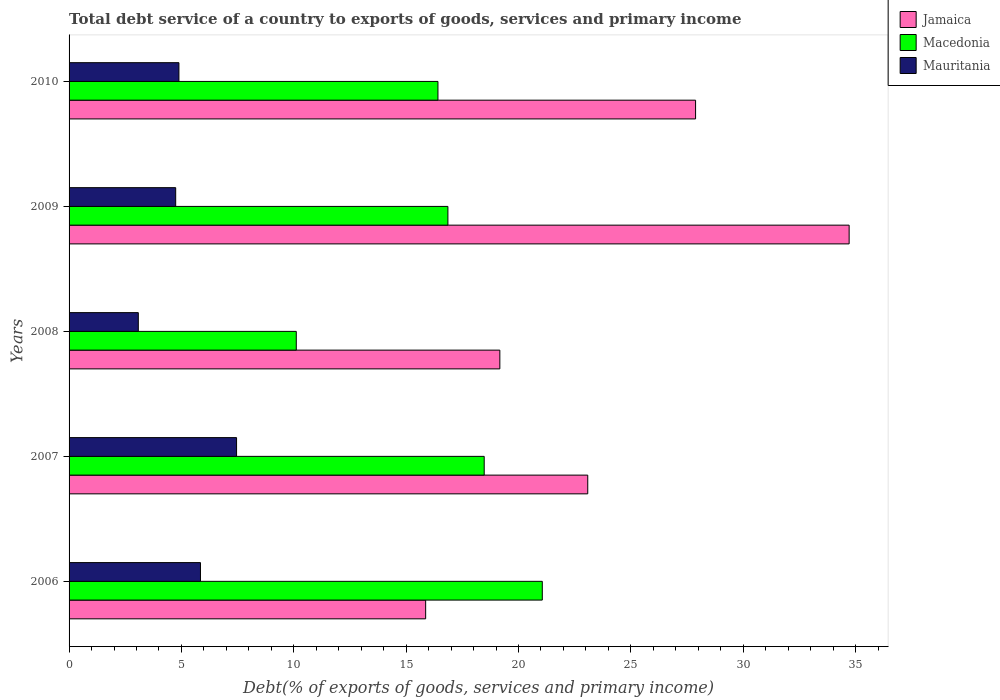In how many cases, is the number of bars for a given year not equal to the number of legend labels?
Give a very brief answer. 0. What is the total debt service in Jamaica in 2009?
Provide a succinct answer. 34.72. Across all years, what is the maximum total debt service in Jamaica?
Your response must be concise. 34.72. Across all years, what is the minimum total debt service in Mauritania?
Provide a succinct answer. 3.08. What is the total total debt service in Mauritania in the graph?
Provide a succinct answer. 26.02. What is the difference between the total debt service in Mauritania in 2007 and that in 2009?
Give a very brief answer. 2.71. What is the difference between the total debt service in Macedonia in 2010 and the total debt service in Jamaica in 2007?
Provide a short and direct response. -6.67. What is the average total debt service in Jamaica per year?
Provide a succinct answer. 24.14. In the year 2006, what is the difference between the total debt service in Mauritania and total debt service in Jamaica?
Make the answer very short. -10.02. What is the ratio of the total debt service in Jamaica in 2007 to that in 2009?
Your answer should be very brief. 0.66. Is the difference between the total debt service in Mauritania in 2006 and 2008 greater than the difference between the total debt service in Jamaica in 2006 and 2008?
Provide a succinct answer. Yes. What is the difference between the highest and the second highest total debt service in Jamaica?
Your response must be concise. 6.83. What is the difference between the highest and the lowest total debt service in Mauritania?
Offer a very short reply. 4.37. In how many years, is the total debt service in Jamaica greater than the average total debt service in Jamaica taken over all years?
Provide a short and direct response. 2. What does the 1st bar from the top in 2008 represents?
Your answer should be compact. Mauritania. What does the 3rd bar from the bottom in 2009 represents?
Make the answer very short. Mauritania. Are all the bars in the graph horizontal?
Make the answer very short. Yes. What is the difference between two consecutive major ticks on the X-axis?
Offer a terse response. 5. Does the graph contain any zero values?
Offer a very short reply. No. Where does the legend appear in the graph?
Your answer should be very brief. Top right. What is the title of the graph?
Keep it short and to the point. Total debt service of a country to exports of goods, services and primary income. What is the label or title of the X-axis?
Keep it short and to the point. Debt(% of exports of goods, services and primary income). What is the Debt(% of exports of goods, services and primary income) in Jamaica in 2006?
Provide a succinct answer. 15.87. What is the Debt(% of exports of goods, services and primary income) of Macedonia in 2006?
Offer a very short reply. 21.06. What is the Debt(% of exports of goods, services and primary income) in Mauritania in 2006?
Offer a very short reply. 5.85. What is the Debt(% of exports of goods, services and primary income) of Jamaica in 2007?
Offer a very short reply. 23.08. What is the Debt(% of exports of goods, services and primary income) in Macedonia in 2007?
Give a very brief answer. 18.47. What is the Debt(% of exports of goods, services and primary income) in Mauritania in 2007?
Give a very brief answer. 7.45. What is the Debt(% of exports of goods, services and primary income) in Jamaica in 2008?
Keep it short and to the point. 19.17. What is the Debt(% of exports of goods, services and primary income) in Macedonia in 2008?
Give a very brief answer. 10.11. What is the Debt(% of exports of goods, services and primary income) of Mauritania in 2008?
Give a very brief answer. 3.08. What is the Debt(% of exports of goods, services and primary income) of Jamaica in 2009?
Offer a very short reply. 34.72. What is the Debt(% of exports of goods, services and primary income) of Macedonia in 2009?
Keep it short and to the point. 16.86. What is the Debt(% of exports of goods, services and primary income) of Mauritania in 2009?
Your answer should be compact. 4.75. What is the Debt(% of exports of goods, services and primary income) in Jamaica in 2010?
Your response must be concise. 27.88. What is the Debt(% of exports of goods, services and primary income) of Macedonia in 2010?
Provide a short and direct response. 16.42. What is the Debt(% of exports of goods, services and primary income) in Mauritania in 2010?
Your response must be concise. 4.89. Across all years, what is the maximum Debt(% of exports of goods, services and primary income) in Jamaica?
Ensure brevity in your answer.  34.72. Across all years, what is the maximum Debt(% of exports of goods, services and primary income) of Macedonia?
Your answer should be compact. 21.06. Across all years, what is the maximum Debt(% of exports of goods, services and primary income) of Mauritania?
Your response must be concise. 7.45. Across all years, what is the minimum Debt(% of exports of goods, services and primary income) in Jamaica?
Your answer should be very brief. 15.87. Across all years, what is the minimum Debt(% of exports of goods, services and primary income) of Macedonia?
Your answer should be very brief. 10.11. Across all years, what is the minimum Debt(% of exports of goods, services and primary income) in Mauritania?
Offer a terse response. 3.08. What is the total Debt(% of exports of goods, services and primary income) in Jamaica in the graph?
Give a very brief answer. 120.72. What is the total Debt(% of exports of goods, services and primary income) of Macedonia in the graph?
Ensure brevity in your answer.  82.92. What is the total Debt(% of exports of goods, services and primary income) of Mauritania in the graph?
Keep it short and to the point. 26.02. What is the difference between the Debt(% of exports of goods, services and primary income) of Jamaica in 2006 and that in 2007?
Your answer should be compact. -7.21. What is the difference between the Debt(% of exports of goods, services and primary income) of Macedonia in 2006 and that in 2007?
Your answer should be compact. 2.59. What is the difference between the Debt(% of exports of goods, services and primary income) in Mauritania in 2006 and that in 2007?
Offer a terse response. -1.61. What is the difference between the Debt(% of exports of goods, services and primary income) of Jamaica in 2006 and that in 2008?
Offer a terse response. -3.3. What is the difference between the Debt(% of exports of goods, services and primary income) of Macedonia in 2006 and that in 2008?
Provide a short and direct response. 10.95. What is the difference between the Debt(% of exports of goods, services and primary income) in Mauritania in 2006 and that in 2008?
Provide a succinct answer. 2.77. What is the difference between the Debt(% of exports of goods, services and primary income) in Jamaica in 2006 and that in 2009?
Your answer should be very brief. -18.85. What is the difference between the Debt(% of exports of goods, services and primary income) in Macedonia in 2006 and that in 2009?
Keep it short and to the point. 4.2. What is the difference between the Debt(% of exports of goods, services and primary income) of Mauritania in 2006 and that in 2009?
Provide a short and direct response. 1.1. What is the difference between the Debt(% of exports of goods, services and primary income) in Jamaica in 2006 and that in 2010?
Ensure brevity in your answer.  -12.01. What is the difference between the Debt(% of exports of goods, services and primary income) in Macedonia in 2006 and that in 2010?
Provide a succinct answer. 4.64. What is the difference between the Debt(% of exports of goods, services and primary income) of Mauritania in 2006 and that in 2010?
Offer a very short reply. 0.96. What is the difference between the Debt(% of exports of goods, services and primary income) of Jamaica in 2007 and that in 2008?
Make the answer very short. 3.91. What is the difference between the Debt(% of exports of goods, services and primary income) of Macedonia in 2007 and that in 2008?
Offer a very short reply. 8.36. What is the difference between the Debt(% of exports of goods, services and primary income) of Mauritania in 2007 and that in 2008?
Give a very brief answer. 4.37. What is the difference between the Debt(% of exports of goods, services and primary income) in Jamaica in 2007 and that in 2009?
Offer a very short reply. -11.63. What is the difference between the Debt(% of exports of goods, services and primary income) in Macedonia in 2007 and that in 2009?
Provide a succinct answer. 1.61. What is the difference between the Debt(% of exports of goods, services and primary income) in Mauritania in 2007 and that in 2009?
Offer a very short reply. 2.71. What is the difference between the Debt(% of exports of goods, services and primary income) of Jamaica in 2007 and that in 2010?
Provide a short and direct response. -4.8. What is the difference between the Debt(% of exports of goods, services and primary income) of Macedonia in 2007 and that in 2010?
Ensure brevity in your answer.  2.06. What is the difference between the Debt(% of exports of goods, services and primary income) in Mauritania in 2007 and that in 2010?
Provide a short and direct response. 2.56. What is the difference between the Debt(% of exports of goods, services and primary income) of Jamaica in 2008 and that in 2009?
Your answer should be very brief. -15.55. What is the difference between the Debt(% of exports of goods, services and primary income) in Macedonia in 2008 and that in 2009?
Give a very brief answer. -6.75. What is the difference between the Debt(% of exports of goods, services and primary income) of Mauritania in 2008 and that in 2009?
Your answer should be very brief. -1.66. What is the difference between the Debt(% of exports of goods, services and primary income) of Jamaica in 2008 and that in 2010?
Offer a terse response. -8.71. What is the difference between the Debt(% of exports of goods, services and primary income) in Macedonia in 2008 and that in 2010?
Offer a terse response. -6.3. What is the difference between the Debt(% of exports of goods, services and primary income) in Mauritania in 2008 and that in 2010?
Give a very brief answer. -1.81. What is the difference between the Debt(% of exports of goods, services and primary income) of Jamaica in 2009 and that in 2010?
Your response must be concise. 6.83. What is the difference between the Debt(% of exports of goods, services and primary income) in Macedonia in 2009 and that in 2010?
Keep it short and to the point. 0.44. What is the difference between the Debt(% of exports of goods, services and primary income) of Mauritania in 2009 and that in 2010?
Provide a short and direct response. -0.14. What is the difference between the Debt(% of exports of goods, services and primary income) of Jamaica in 2006 and the Debt(% of exports of goods, services and primary income) of Macedonia in 2007?
Your answer should be compact. -2.61. What is the difference between the Debt(% of exports of goods, services and primary income) in Jamaica in 2006 and the Debt(% of exports of goods, services and primary income) in Mauritania in 2007?
Offer a very short reply. 8.42. What is the difference between the Debt(% of exports of goods, services and primary income) in Macedonia in 2006 and the Debt(% of exports of goods, services and primary income) in Mauritania in 2007?
Offer a very short reply. 13.61. What is the difference between the Debt(% of exports of goods, services and primary income) of Jamaica in 2006 and the Debt(% of exports of goods, services and primary income) of Macedonia in 2008?
Provide a short and direct response. 5.76. What is the difference between the Debt(% of exports of goods, services and primary income) of Jamaica in 2006 and the Debt(% of exports of goods, services and primary income) of Mauritania in 2008?
Your answer should be very brief. 12.79. What is the difference between the Debt(% of exports of goods, services and primary income) in Macedonia in 2006 and the Debt(% of exports of goods, services and primary income) in Mauritania in 2008?
Your answer should be very brief. 17.98. What is the difference between the Debt(% of exports of goods, services and primary income) in Jamaica in 2006 and the Debt(% of exports of goods, services and primary income) in Macedonia in 2009?
Give a very brief answer. -0.99. What is the difference between the Debt(% of exports of goods, services and primary income) of Jamaica in 2006 and the Debt(% of exports of goods, services and primary income) of Mauritania in 2009?
Your answer should be very brief. 11.12. What is the difference between the Debt(% of exports of goods, services and primary income) of Macedonia in 2006 and the Debt(% of exports of goods, services and primary income) of Mauritania in 2009?
Provide a succinct answer. 16.32. What is the difference between the Debt(% of exports of goods, services and primary income) of Jamaica in 2006 and the Debt(% of exports of goods, services and primary income) of Macedonia in 2010?
Offer a terse response. -0.55. What is the difference between the Debt(% of exports of goods, services and primary income) in Jamaica in 2006 and the Debt(% of exports of goods, services and primary income) in Mauritania in 2010?
Ensure brevity in your answer.  10.98. What is the difference between the Debt(% of exports of goods, services and primary income) of Macedonia in 2006 and the Debt(% of exports of goods, services and primary income) of Mauritania in 2010?
Keep it short and to the point. 16.17. What is the difference between the Debt(% of exports of goods, services and primary income) of Jamaica in 2007 and the Debt(% of exports of goods, services and primary income) of Macedonia in 2008?
Your answer should be compact. 12.97. What is the difference between the Debt(% of exports of goods, services and primary income) of Jamaica in 2007 and the Debt(% of exports of goods, services and primary income) of Mauritania in 2008?
Your answer should be compact. 20. What is the difference between the Debt(% of exports of goods, services and primary income) in Macedonia in 2007 and the Debt(% of exports of goods, services and primary income) in Mauritania in 2008?
Your response must be concise. 15.39. What is the difference between the Debt(% of exports of goods, services and primary income) of Jamaica in 2007 and the Debt(% of exports of goods, services and primary income) of Macedonia in 2009?
Offer a terse response. 6.22. What is the difference between the Debt(% of exports of goods, services and primary income) in Jamaica in 2007 and the Debt(% of exports of goods, services and primary income) in Mauritania in 2009?
Your answer should be compact. 18.34. What is the difference between the Debt(% of exports of goods, services and primary income) of Macedonia in 2007 and the Debt(% of exports of goods, services and primary income) of Mauritania in 2009?
Offer a very short reply. 13.73. What is the difference between the Debt(% of exports of goods, services and primary income) of Jamaica in 2007 and the Debt(% of exports of goods, services and primary income) of Macedonia in 2010?
Your answer should be compact. 6.67. What is the difference between the Debt(% of exports of goods, services and primary income) in Jamaica in 2007 and the Debt(% of exports of goods, services and primary income) in Mauritania in 2010?
Provide a succinct answer. 18.19. What is the difference between the Debt(% of exports of goods, services and primary income) in Macedonia in 2007 and the Debt(% of exports of goods, services and primary income) in Mauritania in 2010?
Offer a very short reply. 13.59. What is the difference between the Debt(% of exports of goods, services and primary income) of Jamaica in 2008 and the Debt(% of exports of goods, services and primary income) of Macedonia in 2009?
Keep it short and to the point. 2.31. What is the difference between the Debt(% of exports of goods, services and primary income) in Jamaica in 2008 and the Debt(% of exports of goods, services and primary income) in Mauritania in 2009?
Provide a short and direct response. 14.43. What is the difference between the Debt(% of exports of goods, services and primary income) of Macedonia in 2008 and the Debt(% of exports of goods, services and primary income) of Mauritania in 2009?
Provide a succinct answer. 5.37. What is the difference between the Debt(% of exports of goods, services and primary income) in Jamaica in 2008 and the Debt(% of exports of goods, services and primary income) in Macedonia in 2010?
Provide a succinct answer. 2.75. What is the difference between the Debt(% of exports of goods, services and primary income) of Jamaica in 2008 and the Debt(% of exports of goods, services and primary income) of Mauritania in 2010?
Give a very brief answer. 14.28. What is the difference between the Debt(% of exports of goods, services and primary income) of Macedonia in 2008 and the Debt(% of exports of goods, services and primary income) of Mauritania in 2010?
Give a very brief answer. 5.22. What is the difference between the Debt(% of exports of goods, services and primary income) in Jamaica in 2009 and the Debt(% of exports of goods, services and primary income) in Macedonia in 2010?
Your answer should be very brief. 18.3. What is the difference between the Debt(% of exports of goods, services and primary income) of Jamaica in 2009 and the Debt(% of exports of goods, services and primary income) of Mauritania in 2010?
Offer a very short reply. 29.83. What is the difference between the Debt(% of exports of goods, services and primary income) of Macedonia in 2009 and the Debt(% of exports of goods, services and primary income) of Mauritania in 2010?
Ensure brevity in your answer.  11.97. What is the average Debt(% of exports of goods, services and primary income) of Jamaica per year?
Your answer should be compact. 24.14. What is the average Debt(% of exports of goods, services and primary income) in Macedonia per year?
Keep it short and to the point. 16.58. What is the average Debt(% of exports of goods, services and primary income) in Mauritania per year?
Your response must be concise. 5.2. In the year 2006, what is the difference between the Debt(% of exports of goods, services and primary income) in Jamaica and Debt(% of exports of goods, services and primary income) in Macedonia?
Your answer should be very brief. -5.19. In the year 2006, what is the difference between the Debt(% of exports of goods, services and primary income) in Jamaica and Debt(% of exports of goods, services and primary income) in Mauritania?
Offer a very short reply. 10.02. In the year 2006, what is the difference between the Debt(% of exports of goods, services and primary income) of Macedonia and Debt(% of exports of goods, services and primary income) of Mauritania?
Provide a succinct answer. 15.21. In the year 2007, what is the difference between the Debt(% of exports of goods, services and primary income) in Jamaica and Debt(% of exports of goods, services and primary income) in Macedonia?
Your answer should be compact. 4.61. In the year 2007, what is the difference between the Debt(% of exports of goods, services and primary income) of Jamaica and Debt(% of exports of goods, services and primary income) of Mauritania?
Provide a short and direct response. 15.63. In the year 2007, what is the difference between the Debt(% of exports of goods, services and primary income) of Macedonia and Debt(% of exports of goods, services and primary income) of Mauritania?
Make the answer very short. 11.02. In the year 2008, what is the difference between the Debt(% of exports of goods, services and primary income) in Jamaica and Debt(% of exports of goods, services and primary income) in Macedonia?
Offer a very short reply. 9.06. In the year 2008, what is the difference between the Debt(% of exports of goods, services and primary income) in Jamaica and Debt(% of exports of goods, services and primary income) in Mauritania?
Provide a succinct answer. 16.09. In the year 2008, what is the difference between the Debt(% of exports of goods, services and primary income) of Macedonia and Debt(% of exports of goods, services and primary income) of Mauritania?
Your answer should be compact. 7.03. In the year 2009, what is the difference between the Debt(% of exports of goods, services and primary income) of Jamaica and Debt(% of exports of goods, services and primary income) of Macedonia?
Make the answer very short. 17.86. In the year 2009, what is the difference between the Debt(% of exports of goods, services and primary income) of Jamaica and Debt(% of exports of goods, services and primary income) of Mauritania?
Your answer should be compact. 29.97. In the year 2009, what is the difference between the Debt(% of exports of goods, services and primary income) of Macedonia and Debt(% of exports of goods, services and primary income) of Mauritania?
Ensure brevity in your answer.  12.11. In the year 2010, what is the difference between the Debt(% of exports of goods, services and primary income) in Jamaica and Debt(% of exports of goods, services and primary income) in Macedonia?
Make the answer very short. 11.47. In the year 2010, what is the difference between the Debt(% of exports of goods, services and primary income) in Jamaica and Debt(% of exports of goods, services and primary income) in Mauritania?
Give a very brief answer. 22.99. In the year 2010, what is the difference between the Debt(% of exports of goods, services and primary income) of Macedonia and Debt(% of exports of goods, services and primary income) of Mauritania?
Make the answer very short. 11.53. What is the ratio of the Debt(% of exports of goods, services and primary income) in Jamaica in 2006 to that in 2007?
Your answer should be very brief. 0.69. What is the ratio of the Debt(% of exports of goods, services and primary income) in Macedonia in 2006 to that in 2007?
Keep it short and to the point. 1.14. What is the ratio of the Debt(% of exports of goods, services and primary income) in Mauritania in 2006 to that in 2007?
Give a very brief answer. 0.78. What is the ratio of the Debt(% of exports of goods, services and primary income) of Jamaica in 2006 to that in 2008?
Give a very brief answer. 0.83. What is the ratio of the Debt(% of exports of goods, services and primary income) of Macedonia in 2006 to that in 2008?
Provide a succinct answer. 2.08. What is the ratio of the Debt(% of exports of goods, services and primary income) of Mauritania in 2006 to that in 2008?
Give a very brief answer. 1.9. What is the ratio of the Debt(% of exports of goods, services and primary income) in Jamaica in 2006 to that in 2009?
Offer a very short reply. 0.46. What is the ratio of the Debt(% of exports of goods, services and primary income) in Macedonia in 2006 to that in 2009?
Give a very brief answer. 1.25. What is the ratio of the Debt(% of exports of goods, services and primary income) of Mauritania in 2006 to that in 2009?
Offer a terse response. 1.23. What is the ratio of the Debt(% of exports of goods, services and primary income) of Jamaica in 2006 to that in 2010?
Your answer should be compact. 0.57. What is the ratio of the Debt(% of exports of goods, services and primary income) of Macedonia in 2006 to that in 2010?
Offer a very short reply. 1.28. What is the ratio of the Debt(% of exports of goods, services and primary income) in Mauritania in 2006 to that in 2010?
Make the answer very short. 1.2. What is the ratio of the Debt(% of exports of goods, services and primary income) of Jamaica in 2007 to that in 2008?
Keep it short and to the point. 1.2. What is the ratio of the Debt(% of exports of goods, services and primary income) of Macedonia in 2007 to that in 2008?
Ensure brevity in your answer.  1.83. What is the ratio of the Debt(% of exports of goods, services and primary income) in Mauritania in 2007 to that in 2008?
Ensure brevity in your answer.  2.42. What is the ratio of the Debt(% of exports of goods, services and primary income) in Jamaica in 2007 to that in 2009?
Your answer should be compact. 0.66. What is the ratio of the Debt(% of exports of goods, services and primary income) in Macedonia in 2007 to that in 2009?
Ensure brevity in your answer.  1.1. What is the ratio of the Debt(% of exports of goods, services and primary income) of Mauritania in 2007 to that in 2009?
Provide a succinct answer. 1.57. What is the ratio of the Debt(% of exports of goods, services and primary income) in Jamaica in 2007 to that in 2010?
Make the answer very short. 0.83. What is the ratio of the Debt(% of exports of goods, services and primary income) of Macedonia in 2007 to that in 2010?
Provide a short and direct response. 1.13. What is the ratio of the Debt(% of exports of goods, services and primary income) in Mauritania in 2007 to that in 2010?
Keep it short and to the point. 1.52. What is the ratio of the Debt(% of exports of goods, services and primary income) of Jamaica in 2008 to that in 2009?
Give a very brief answer. 0.55. What is the ratio of the Debt(% of exports of goods, services and primary income) of Macedonia in 2008 to that in 2009?
Provide a short and direct response. 0.6. What is the ratio of the Debt(% of exports of goods, services and primary income) in Mauritania in 2008 to that in 2009?
Ensure brevity in your answer.  0.65. What is the ratio of the Debt(% of exports of goods, services and primary income) of Jamaica in 2008 to that in 2010?
Give a very brief answer. 0.69. What is the ratio of the Debt(% of exports of goods, services and primary income) of Macedonia in 2008 to that in 2010?
Your response must be concise. 0.62. What is the ratio of the Debt(% of exports of goods, services and primary income) of Mauritania in 2008 to that in 2010?
Provide a short and direct response. 0.63. What is the ratio of the Debt(% of exports of goods, services and primary income) of Jamaica in 2009 to that in 2010?
Provide a short and direct response. 1.25. What is the ratio of the Debt(% of exports of goods, services and primary income) in Mauritania in 2009 to that in 2010?
Offer a terse response. 0.97. What is the difference between the highest and the second highest Debt(% of exports of goods, services and primary income) of Jamaica?
Your answer should be compact. 6.83. What is the difference between the highest and the second highest Debt(% of exports of goods, services and primary income) in Macedonia?
Give a very brief answer. 2.59. What is the difference between the highest and the second highest Debt(% of exports of goods, services and primary income) of Mauritania?
Keep it short and to the point. 1.61. What is the difference between the highest and the lowest Debt(% of exports of goods, services and primary income) in Jamaica?
Provide a succinct answer. 18.85. What is the difference between the highest and the lowest Debt(% of exports of goods, services and primary income) of Macedonia?
Provide a succinct answer. 10.95. What is the difference between the highest and the lowest Debt(% of exports of goods, services and primary income) in Mauritania?
Offer a terse response. 4.37. 